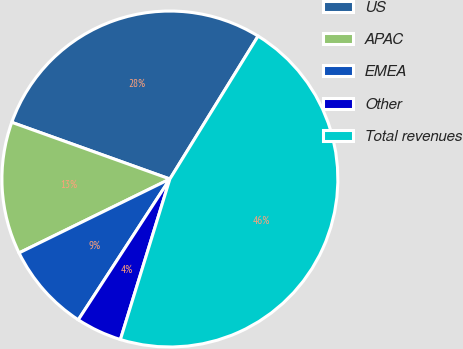Convert chart. <chart><loc_0><loc_0><loc_500><loc_500><pie_chart><fcel>US<fcel>APAC<fcel>EMEA<fcel>Other<fcel>Total revenues<nl><fcel>28.32%<fcel>12.73%<fcel>8.57%<fcel>4.42%<fcel>45.96%<nl></chart> 